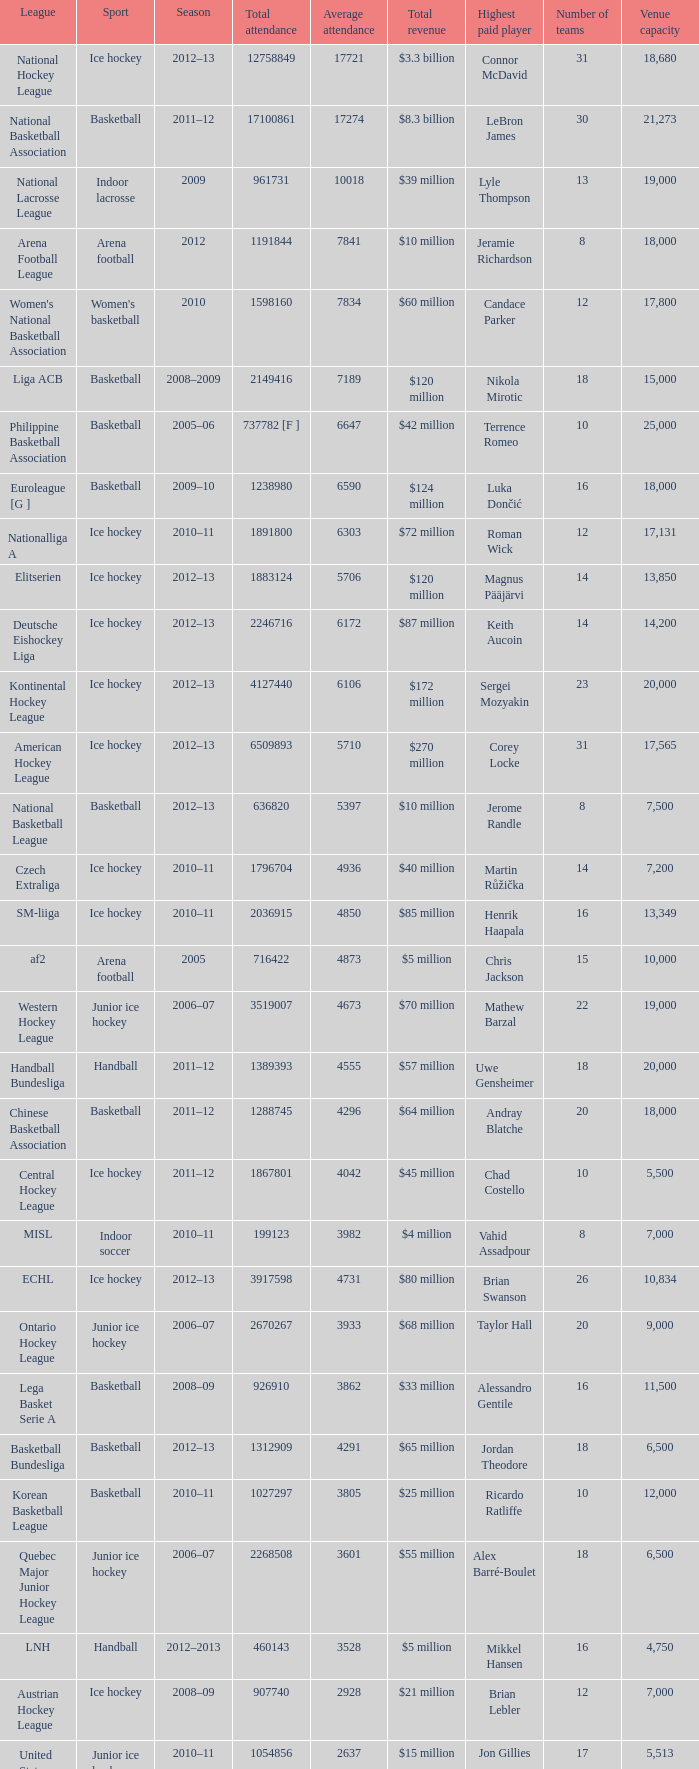What's the average attendance of the league with a total attendance of 2268508? 3601.0. 